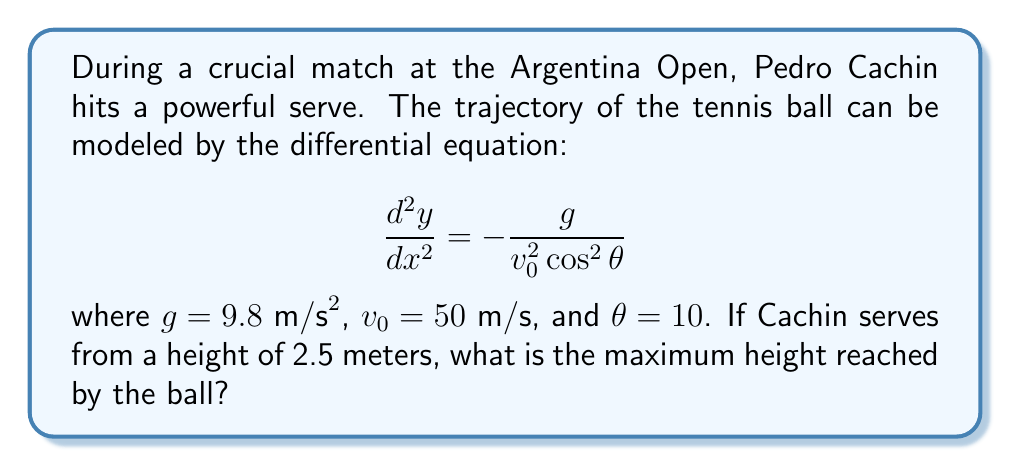Can you answer this question? Let's approach this step-by-step:

1) The general solution to this differential equation is:

   $$y = -\frac{g}{2v_0^2 \cos^2 \theta}x^2 + (\tan \theta)x + C$$

2) We know the initial height, so we can find $C$:
   When $x = 0$, $y = 2.5$
   $2.5 = C$

3) So our specific solution is:

   $$y = -\frac{g}{2v_0^2 \cos^2 \theta}x^2 + (\tan \theta)x + 2.5$$

4) To find the maximum height, we need to find where $\frac{dy}{dx} = 0$:

   $$\frac{dy}{dx} = -\frac{g}{v_0^2 \cos^2 \theta}x + \tan \theta$$

5) Set this equal to zero and solve for $x$:

   $$-\frac{g}{v_0^2 \cos^2 \theta}x + \tan \theta = 0$$
   $$x = \frac{v_0^2 \sin \theta \cos \theta}{g}$$

6) Now, let's substitute our values:
   $g = 9.8 \text{ m/s}^2$, $v_0 = 50 \text{ m/s}$, $\theta = 10°$

   $$x = \frac{50^2 \sin 10° \cos 10°}{9.8} \approx 44.31 \text{ m}$$

7) To find the maximum height, we substitute this $x$ value back into our equation for $y$:

   $$y = -\frac{9.8}{2(50^2 \cos^2 10°)}(44.31^2) + (\tan 10°)(44.31) + 2.5$$

8) Calculating this gives us approximately 6.37 meters.
Answer: 6.37 meters 